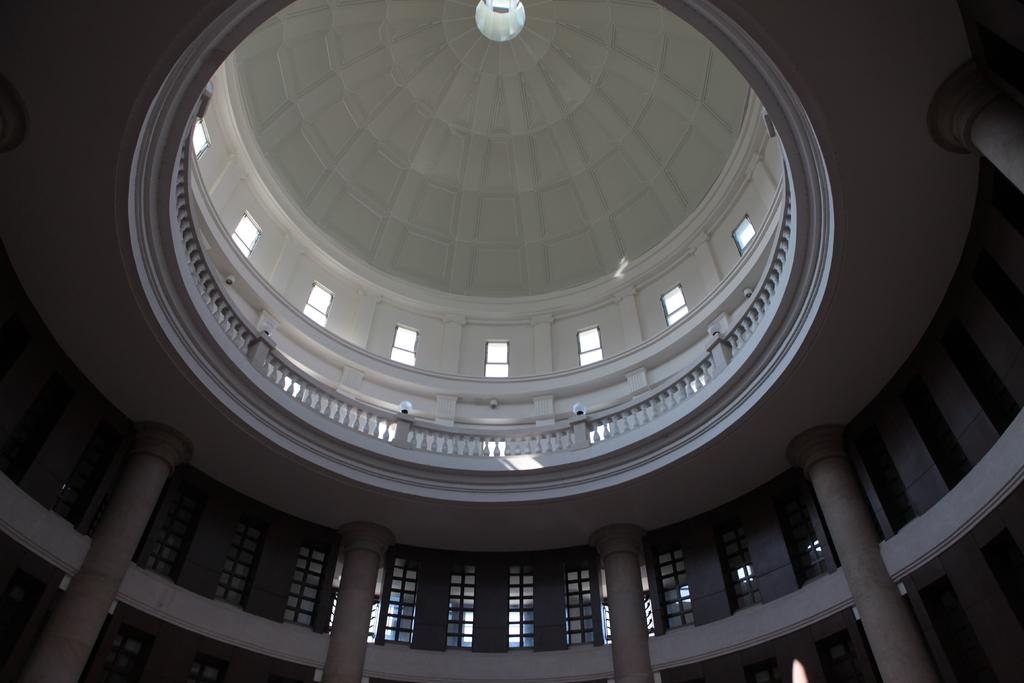What type of location is depicted in the image? The image is an inside view of a building. What architectural feature can be seen in the image? There is a fence in the image. What allows natural light to enter the building in the image? There are windows in the image. What structural elements support the building in the image? There are pillars in the image. Can you describe any other objects present in the image? There are other objects in the image, but their specific details are not mentioned in the provided facts. What type of ornament is hanging from the grandmother's neck in the image? There is no grandmother or ornament present in the image. 